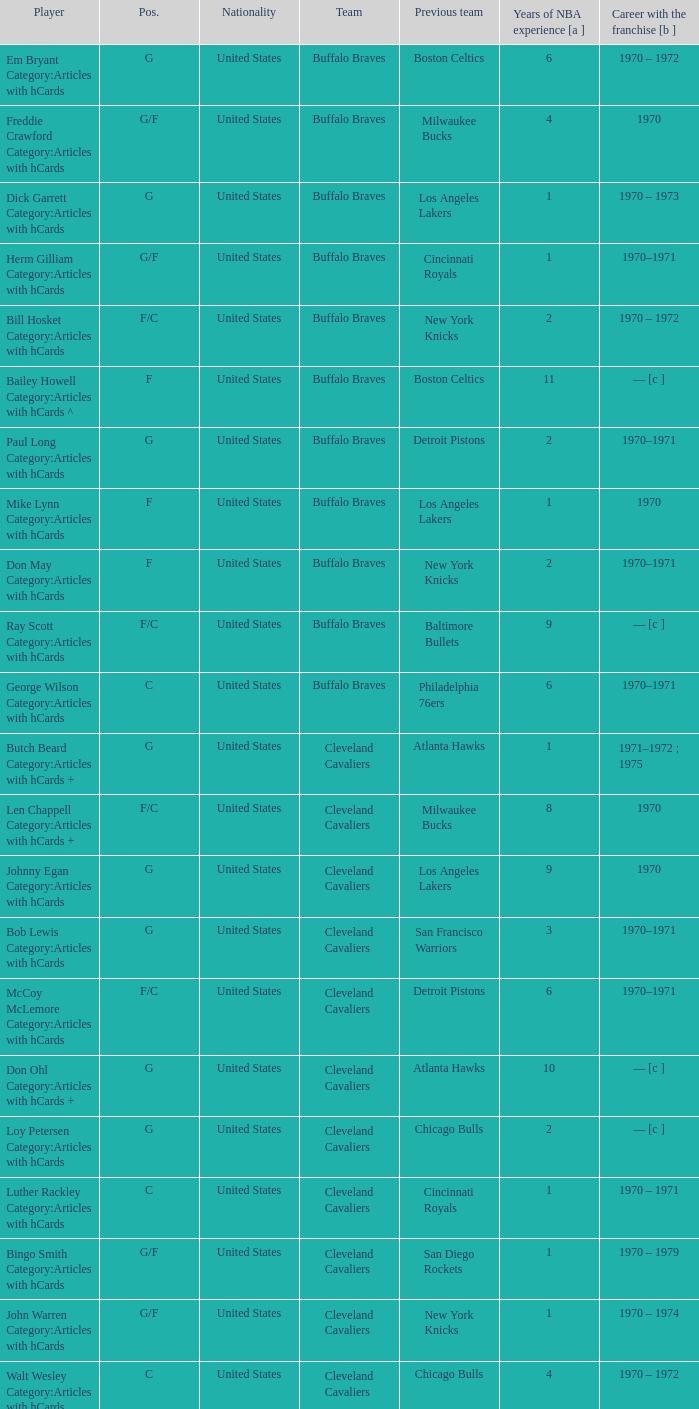Could you parse the entire table? {'header': ['Player', 'Pos.', 'Nationality', 'Team', 'Previous team', 'Years of NBA experience [a ]', 'Career with the franchise [b ]'], 'rows': [['Em Bryant Category:Articles with hCards', 'G', 'United States', 'Buffalo Braves', 'Boston Celtics', '6', '1970 – 1972'], ['Freddie Crawford Category:Articles with hCards', 'G/F', 'United States', 'Buffalo Braves', 'Milwaukee Bucks', '4', '1970'], ['Dick Garrett Category:Articles with hCards', 'G', 'United States', 'Buffalo Braves', 'Los Angeles Lakers', '1', '1970 – 1973'], ['Herm Gilliam Category:Articles with hCards', 'G/F', 'United States', 'Buffalo Braves', 'Cincinnati Royals', '1', '1970–1971'], ['Bill Hosket Category:Articles with hCards', 'F/C', 'United States', 'Buffalo Braves', 'New York Knicks', '2', '1970 – 1972'], ['Bailey Howell Category:Articles with hCards ^', 'F', 'United States', 'Buffalo Braves', 'Boston Celtics', '11', '— [c ]'], ['Paul Long Category:Articles with hCards', 'G', 'United States', 'Buffalo Braves', 'Detroit Pistons', '2', '1970–1971'], ['Mike Lynn Category:Articles with hCards', 'F', 'United States', 'Buffalo Braves', 'Los Angeles Lakers', '1', '1970'], ['Don May Category:Articles with hCards', 'F', 'United States', 'Buffalo Braves', 'New York Knicks', '2', '1970–1971'], ['Ray Scott Category:Articles with hCards', 'F/C', 'United States', 'Buffalo Braves', 'Baltimore Bullets', '9', '— [c ]'], ['George Wilson Category:Articles with hCards', 'C', 'United States', 'Buffalo Braves', 'Philadelphia 76ers', '6', '1970–1971'], ['Butch Beard Category:Articles with hCards +', 'G', 'United States', 'Cleveland Cavaliers', 'Atlanta Hawks', '1', '1971–1972 ; 1975'], ['Len Chappell Category:Articles with hCards +', 'F/C', 'United States', 'Cleveland Cavaliers', 'Milwaukee Bucks', '8', '1970'], ['Johnny Egan Category:Articles with hCards', 'G', 'United States', 'Cleveland Cavaliers', 'Los Angeles Lakers', '9', '1970'], ['Bob Lewis Category:Articles with hCards', 'G', 'United States', 'Cleveland Cavaliers', 'San Francisco Warriors', '3', '1970–1971'], ['McCoy McLemore Category:Articles with hCards', 'F/C', 'United States', 'Cleveland Cavaliers', 'Detroit Pistons', '6', '1970–1971'], ['Don Ohl Category:Articles with hCards +', 'G', 'United States', 'Cleveland Cavaliers', 'Atlanta Hawks', '10', '— [c ]'], ['Loy Petersen Category:Articles with hCards', 'G', 'United States', 'Cleveland Cavaliers', 'Chicago Bulls', '2', '— [c ]'], ['Luther Rackley Category:Articles with hCards', 'C', 'United States', 'Cleveland Cavaliers', 'Cincinnati Royals', '1', '1970 – 1971'], ['Bingo Smith Category:Articles with hCards', 'G/F', 'United States', 'Cleveland Cavaliers', 'San Diego Rockets', '1', '1970 – 1979'], ['John Warren Category:Articles with hCards', 'G/F', 'United States', 'Cleveland Cavaliers', 'New York Knicks', '1', '1970 – 1974'], ['Walt Wesley Category:Articles with hCards', 'C', 'United States', 'Cleveland Cavaliers', 'Chicago Bulls', '4', '1970 – 1972'], ['Rick Adelman Category:Articles with hCards', 'G', 'United States', 'Portland Trail Blazers', 'San Diego Rockets', '2', '1970 – 1973'], ['Jerry Chambers Category:Articles with hCards', 'F', 'United States', 'Portland Trail Blazers', 'Phoenix Suns', '2', '— [c ]'], ['LeRoy Ellis Category:Articles with hCards', 'F/C', 'United States', 'Portland Trail Blazers', 'Baltimore Bullets', '8', '1970–1971'], ['Fred Hetzel Category:Articles with hCards', 'F/C', 'United States', 'Portland Trail Blazers', 'Philadelphia 76ers', '5', '— [c ]'], ['Joe Kennedy Category:Articles with hCards', 'F', 'United States', 'Portland Trail Blazers', 'Seattle SuperSonics', '2', '— [c ]'], ['Ed Manning Category:Articles with hCards', 'F', 'United States', 'Portland Trail Blazers', 'Chicago Bulls', '3', '1970–1971'], ['Stan McKenzie Category:Articles with hCards', 'G/F', 'United States', 'Portland Trail Blazers', 'Phoenix Suns', '3', '1970 – 1972'], ['Dorie Murrey Category:Articles with hCards', 'F/C', 'United States', 'Portland Trail Blazers', 'Seattle SuperSonics', '4', '1970'], ['Pat Riley Category:Articles with hCards', 'G/F', 'United States', 'Portland Trail Blazers', 'San Diego Rockets', '3', '— [c ]'], ['Dale Schlueter Category:Articles with hCards', 'C', 'United States', 'Portland Trail Blazers', 'San Francisco Warriors', '2', '1970 – 1972 ; 1977–1978'], ['Larry Siegfried Category:Articles with hCards', 'F', 'United States', 'Portland Trail Blazers', 'Boston Celtics', '7', '— [c ]']]} How many years of nba experience does the individual who plays position g for the portland trail blazers have? 2.0. 